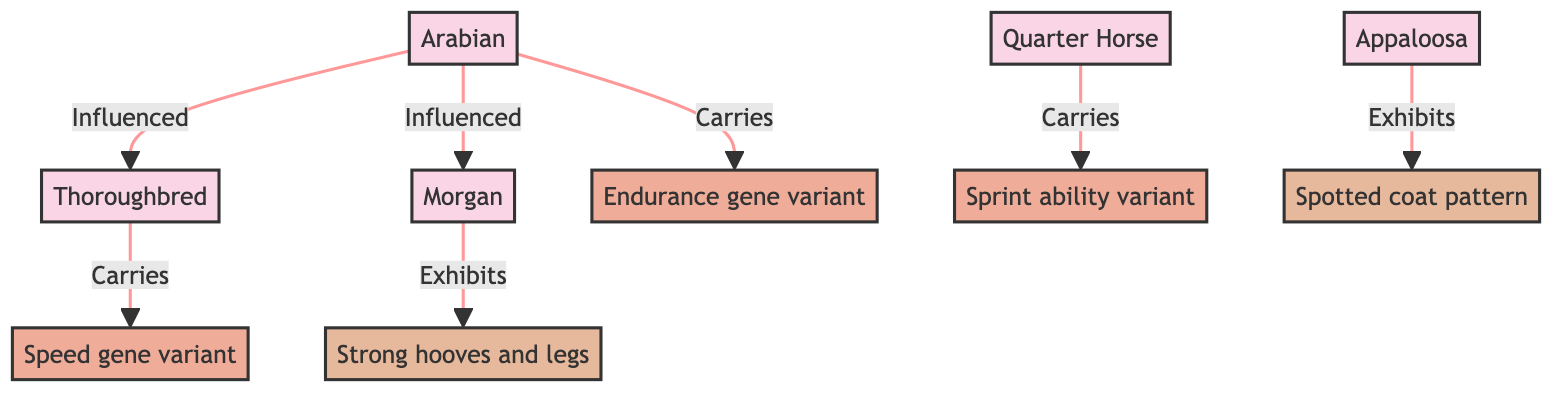What are the horse breeds mentioned in the diagram? The diagram lists five horse breeds: Thoroughbred, Arabian, Quarter Horse, Morgan, and Appaloosa. These are represented as distinct nodes or boxes in the diagram, each labeled clearly.
Answer: Thoroughbred, Arabian, Quarter Horse, Morgan, Appaloosa Which breed is associated with the speed gene variant? The Thoroughbred is connected by an arrow labeled "Carries" to the "Speed gene variant." This relationship indicates that the Thoroughbred breed has this specific genetic variant.
Answer: Thoroughbred How many genetic variants are shown in the diagram? The diagram features three genetic variants: Speed gene variant, Endurance gene variant, and Sprint ability variant, each represented by its own node. Counting these nodes gives a total of three.
Answer: 3 Which breed exhibits strong hooves and legs? The Morgan breed is directly linked by the label "Exhibits" to the "Strong hooves and legs" trait in the diagram. This indicates that this breed is characterized by this specific trait.
Answer: Morgan Which breed is influenced by the Arabian breed? The diagram shows two arrows indicating that the Arabian breed "Influenced" both the Thoroughbred and the Morgan breeds. Therefore, both breeds are influenced by the Arabian.
Answer: Thoroughbred, Morgan What trait is associated with the Appaloosa breed? The diagram indicates that the Appaloosa breed "Exhibits" the "Spotted coat pattern" trait. This shows that the Appaloosa is recognized for having this particular characteristic.
Answer: Spotted coat pattern How many times does the Arabian breed influence other breeds? The Arabian breed influences two other breeds according to the diagram, as it has two arrows pointing to the Thoroughbred and Morgan breeds. This shows the impact of Arabian genetics on these other breeds.
Answer: 2 Which trait is linked to the Quarter Horse breed? The Quarter Horse breed is not directly linked to a trait in the diagram; instead, it is described as carrying the "Sprint ability variant," which suggests a genetic characteristic rather than an exhibited trait.
Answer: None What gene variant is specifically related to endurance? The "Endurance gene variant" is explicitly labeled in the diagram, and it is connected to the Arabian breed, which carries this specific genetic trait.
Answer: Endurance gene variant 